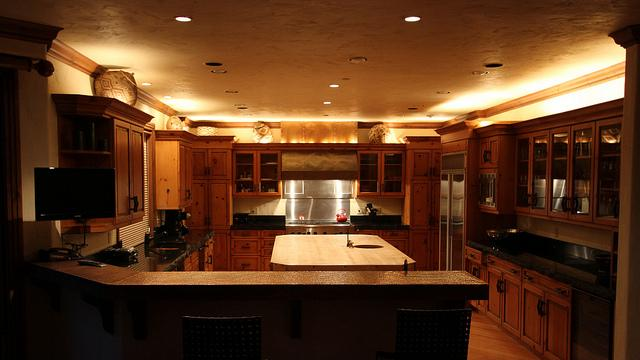What color is the water kettle on the top of the oven in the back of the kitchen? Please explain your reasoning. red. It's red. 